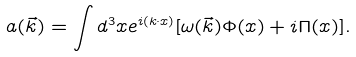Convert formula to latex. <formula><loc_0><loc_0><loc_500><loc_500>a ( \vec { k } ) = \int d ^ { 3 } x e ^ { i ( k \cdot x ) } [ \omega ( \vec { k } ) \Phi ( x ) + i \Pi ( x ) ] .</formula> 